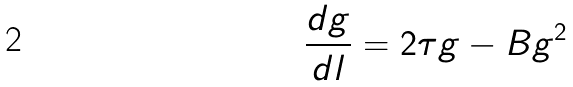Convert formula to latex. <formula><loc_0><loc_0><loc_500><loc_500>\frac { d g } { d l } = 2 \tau g - B g ^ { 2 }</formula> 